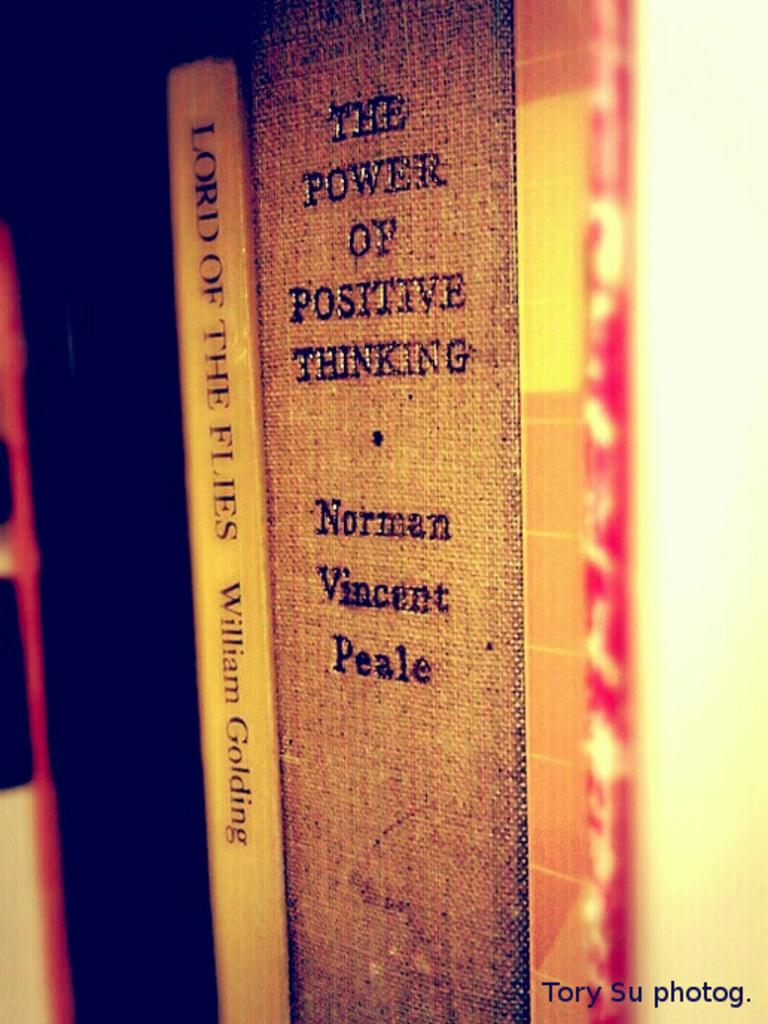<image>
Share a concise interpretation of the image provided. Multiple books including The power of positive thinking by Norman Vincent Peale. 